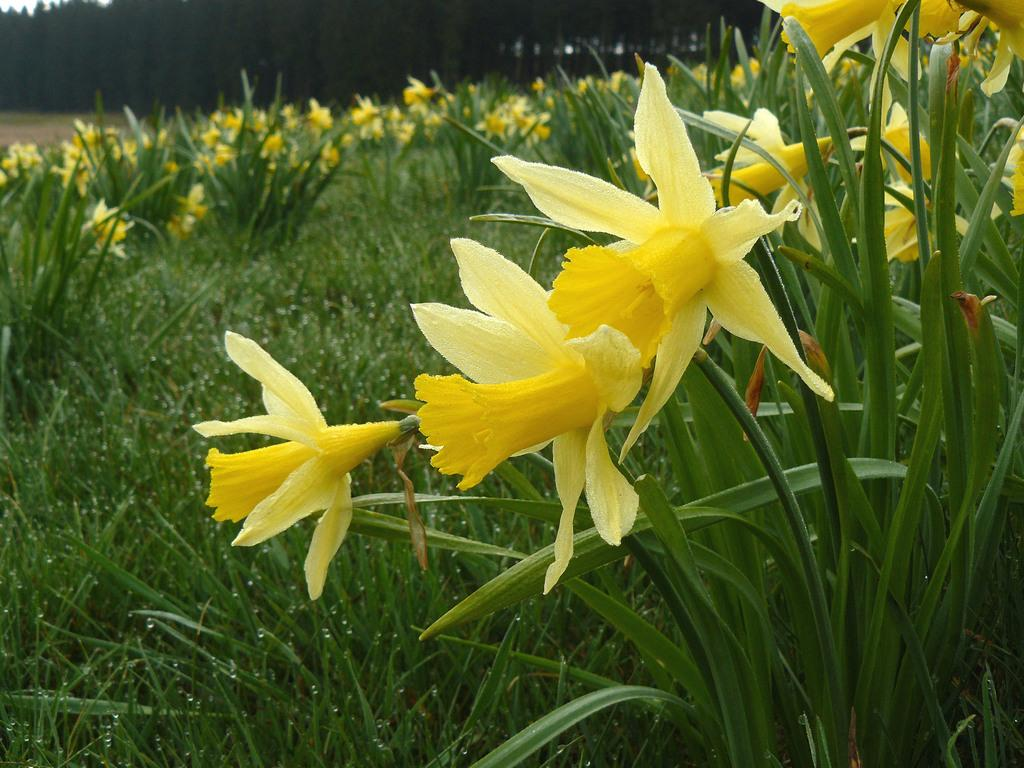What type of vegetation can be seen in the image? There are flowers, plants, grass, and trees in the image. Can you describe the different types of vegetation present? The image contains flowers, plants, grass, and trees. What is the natural environment depicted in the image? The image shows a natural environment with various types of vegetation, including flowers, plants, grass, and trees. What type of hammer can be seen in the image? There is no hammer present in the image; it features various types of vegetation, including flowers, plants, grass, and trees. How many matches are visible in the image? There are no matches present in the image. 